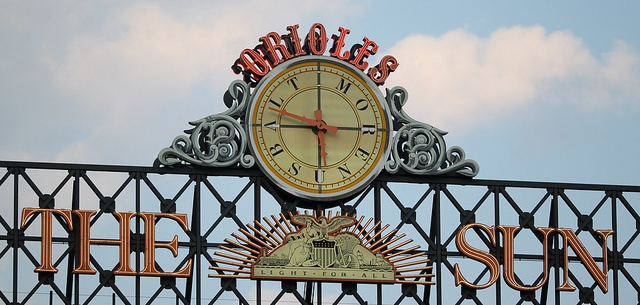Describe the objects in this image and their specific colors. I can see a clock in darkgray, olive, and black tones in this image. 